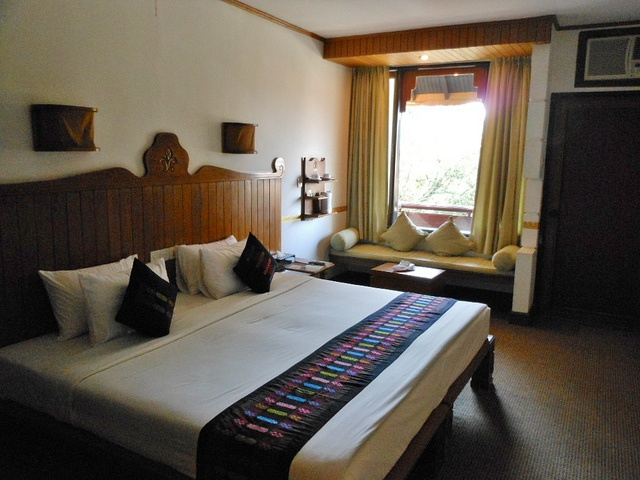Describe the objects in this image and their specific colors. I can see bed in gray, black, darkgray, and maroon tones and couch in gray, olive, black, and tan tones in this image. 